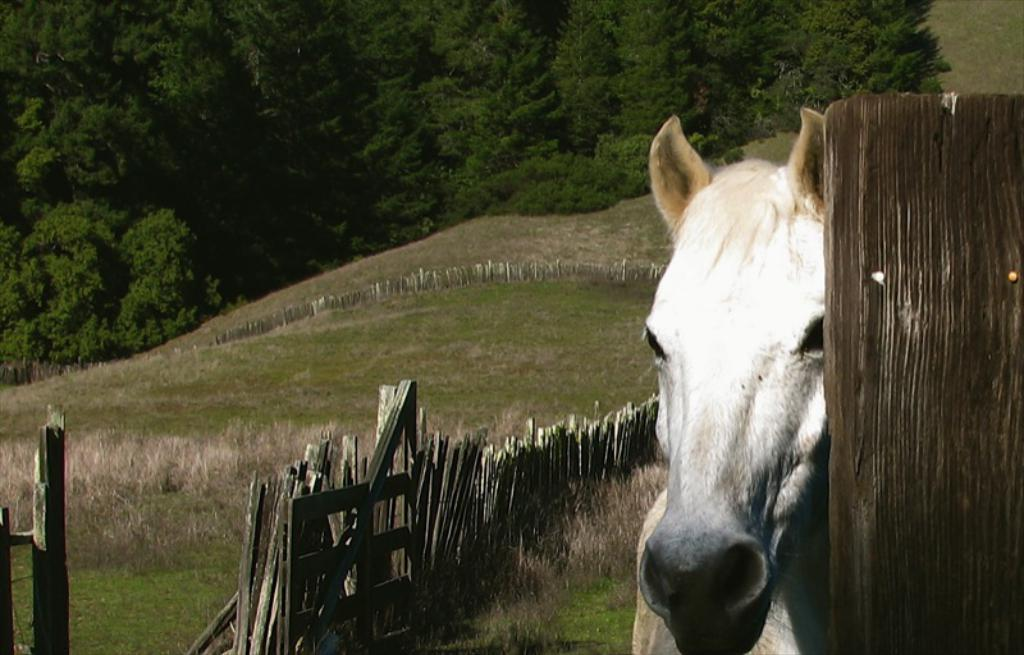What animal is present in the image? There is a horse in the image. What type of fencing can be seen in the image? There is wooden fencing in the image. What type of vegetation is visible in the background of the image? There is grass visible in the background of the image. What other natural elements can be seen in the background of the image? There are trees in the background of the image. What type of beds are visible in the image? There are no beds present in the image. What emotion is the horse expressing towards the wooden fencing in the image? The image does not convey any emotions or feelings of the horse, so it cannot be determined how the horse feels about the wooden fencing. 